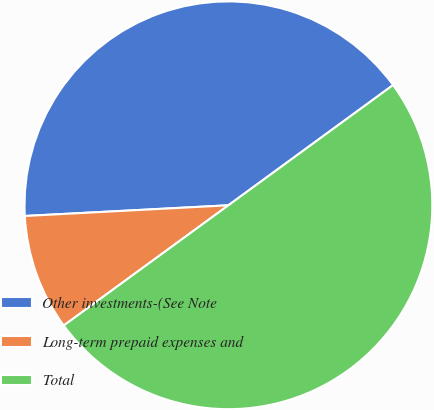<chart> <loc_0><loc_0><loc_500><loc_500><pie_chart><fcel>Other investments-(See Note<fcel>Long-term prepaid expenses and<fcel>Total<nl><fcel>40.8%<fcel>9.2%<fcel>50.0%<nl></chart> 